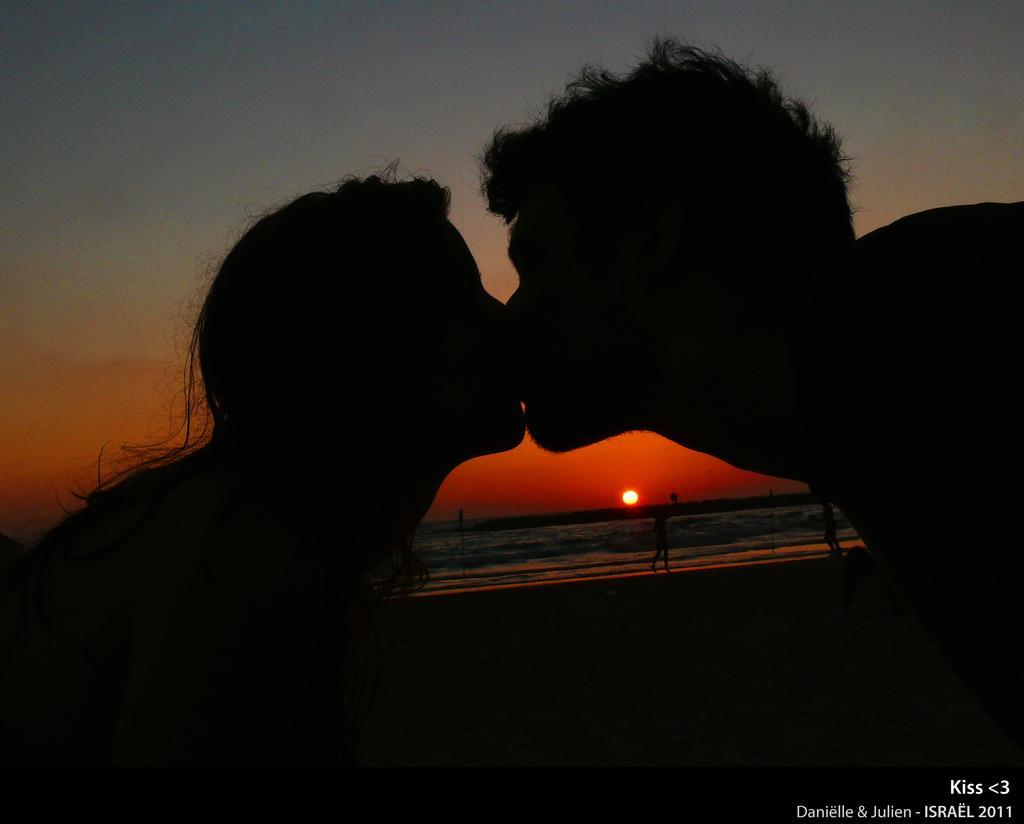Can you describe this image briefly? In the background we can see sun, water and people. Here we can see a man and a woman kissing each other. In the bottom right corner of the picture we can see water mark. 